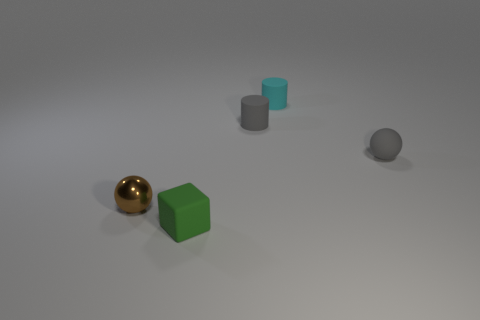What is the shape of the small object that is to the left of the cyan rubber cylinder and to the right of the small green matte cube?
Provide a short and direct response. Cylinder. What number of cyan matte things are to the left of the small matte object in front of the small gray matte sphere?
Provide a short and direct response. 0. Do the small sphere that is behind the brown metallic ball and the cyan object have the same material?
Offer a very short reply. Yes. Is there any other thing that is made of the same material as the tiny brown object?
Your answer should be very brief. No. There is a gray thing that is left of the tiny gray sphere; is its shape the same as the thing that is to the left of the green block?
Offer a very short reply. No. What number of other objects are the same color as the matte sphere?
Your answer should be very brief. 1. Is the size of the thing left of the cube the same as the small cyan rubber object?
Offer a very short reply. Yes. Are the ball that is on the left side of the small gray sphere and the small sphere to the right of the small rubber cube made of the same material?
Offer a very short reply. No. Are there any gray rubber balls of the same size as the brown metallic thing?
Provide a succinct answer. Yes. There is a tiny gray thing that is to the right of the gray thing that is on the left side of the tiny gray rubber object that is to the right of the cyan matte cylinder; what is its shape?
Give a very brief answer. Sphere. 